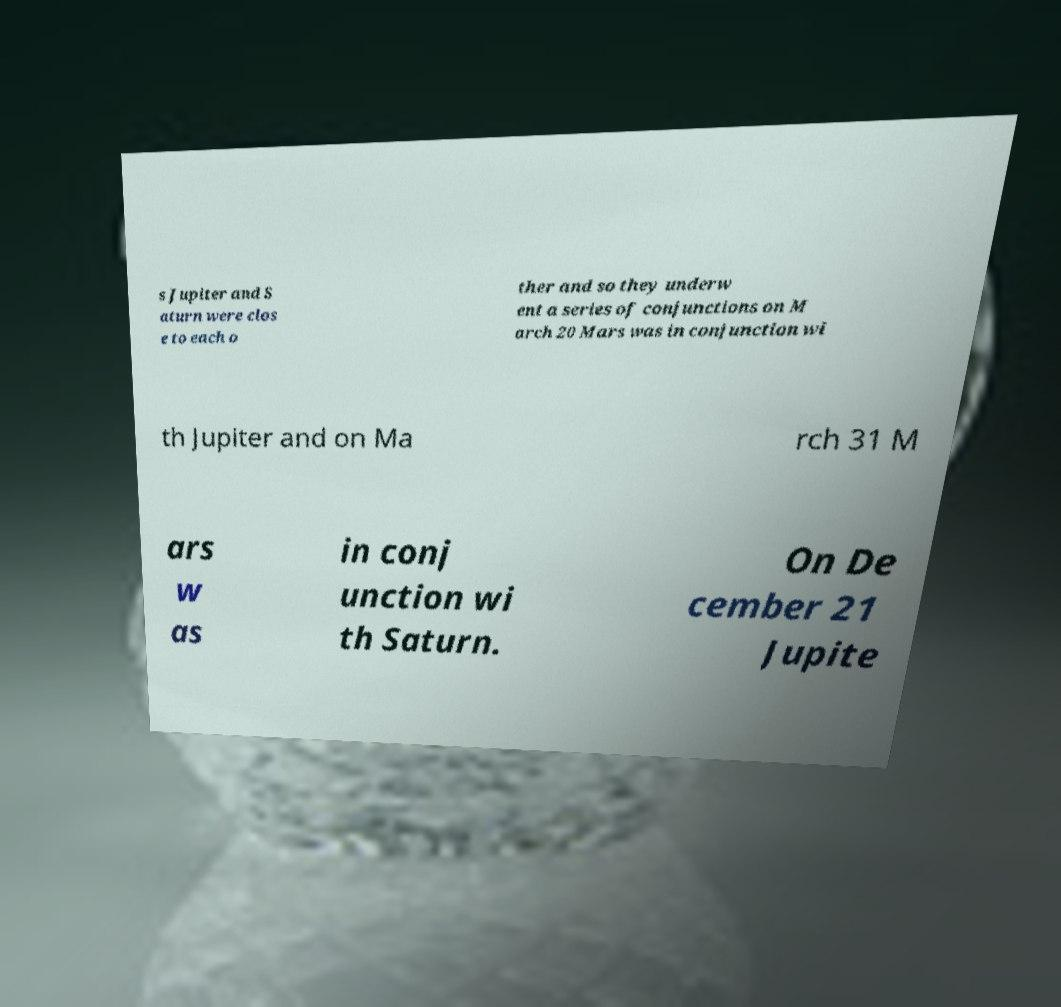For documentation purposes, I need the text within this image transcribed. Could you provide that? s Jupiter and S aturn were clos e to each o ther and so they underw ent a series of conjunctions on M arch 20 Mars was in conjunction wi th Jupiter and on Ma rch 31 M ars w as in conj unction wi th Saturn. On De cember 21 Jupite 